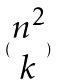Convert formula to latex. <formula><loc_0><loc_0><loc_500><loc_500>( \begin{matrix} n ^ { 2 } \\ k \end{matrix} )</formula> 